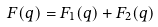<formula> <loc_0><loc_0><loc_500><loc_500>F ( q ) = F _ { 1 } ( q ) + F _ { 2 } ( q )</formula> 